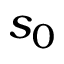Convert formula to latex. <formula><loc_0><loc_0><loc_500><loc_500>s _ { 0 }</formula> 